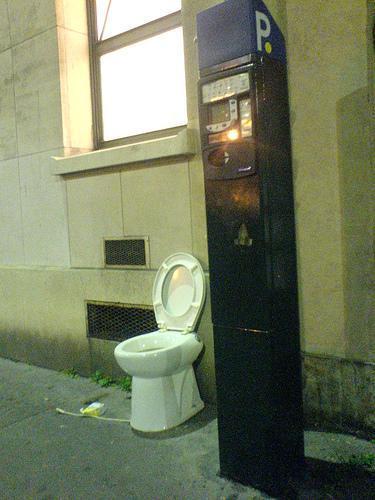How many toilets are there?
Give a very brief answer. 1. How many metal grates are on the wall?
Give a very brief answer. 2. How many windows are there?
Give a very brief answer. 1. How many windows are in the photo?
Give a very brief answer. 1. 